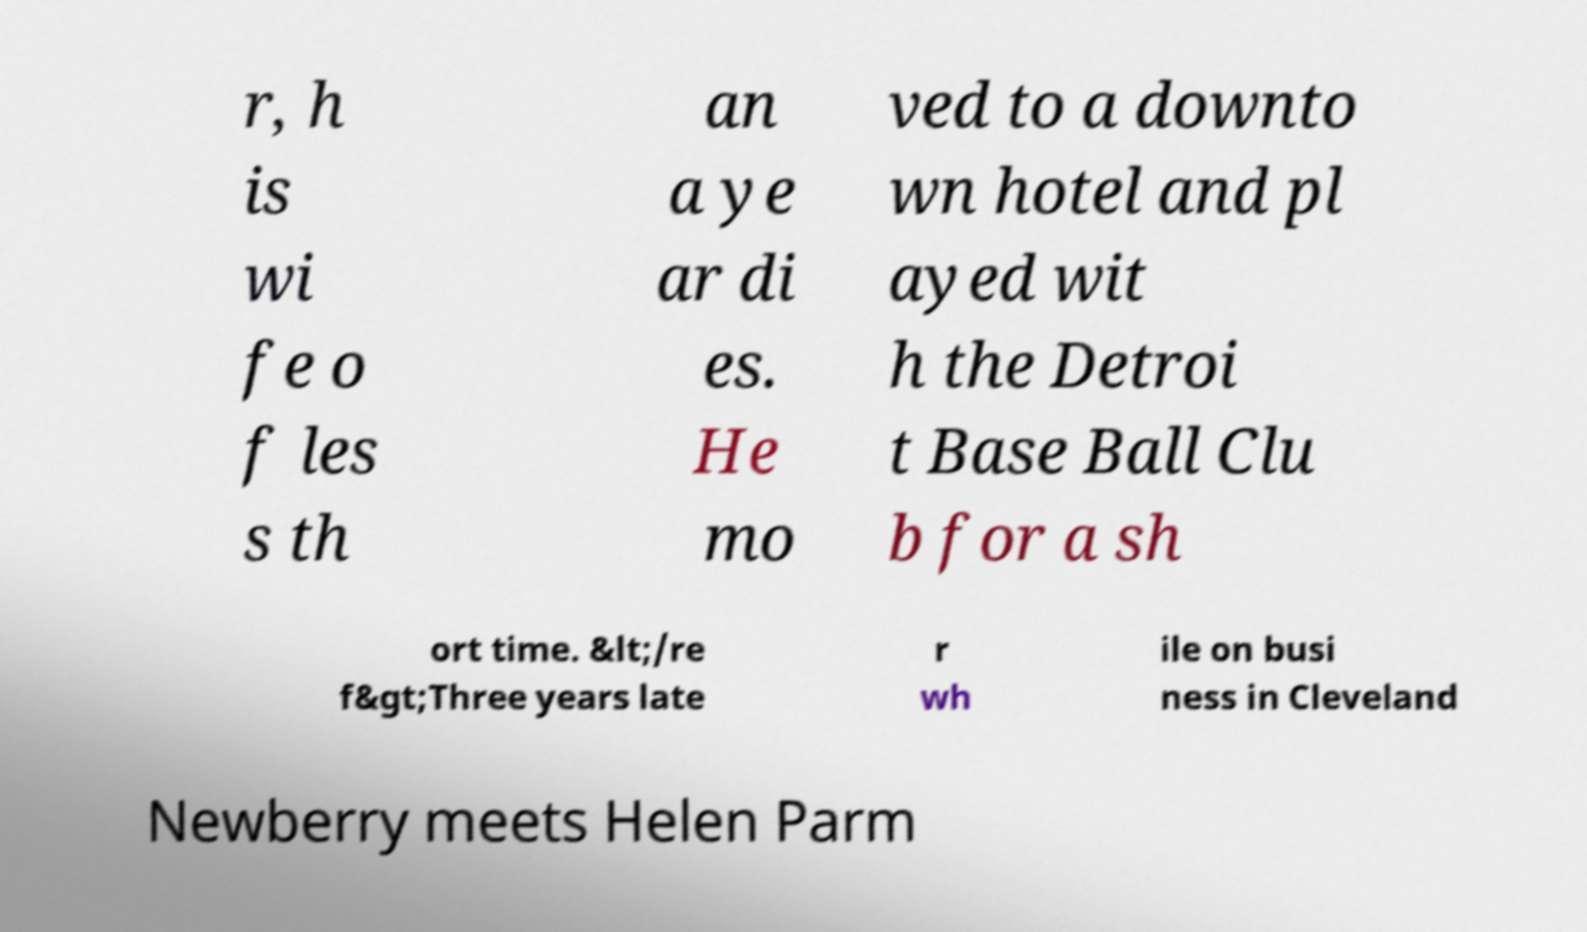What messages or text are displayed in this image? I need them in a readable, typed format. r, h is wi fe o f les s th an a ye ar di es. He mo ved to a downto wn hotel and pl ayed wit h the Detroi t Base Ball Clu b for a sh ort time. &lt;/re f&gt;Three years late r wh ile on busi ness in Cleveland Newberry meets Helen Parm 